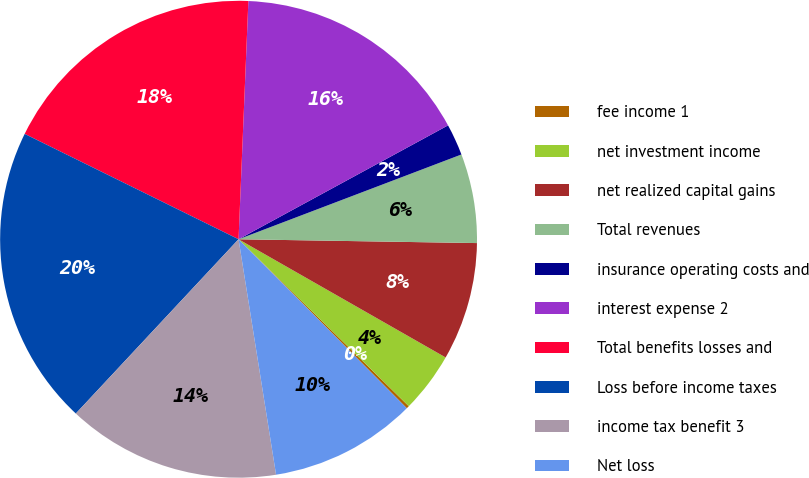<chart> <loc_0><loc_0><loc_500><loc_500><pie_chart><fcel>fee income 1<fcel>net investment income<fcel>net realized capital gains<fcel>Total revenues<fcel>insurance operating costs and<fcel>interest expense 2<fcel>Total benefits losses and<fcel>Loss before income taxes<fcel>income tax benefit 3<fcel>Net loss<nl><fcel>0.19%<fcel>4.09%<fcel>8.0%<fcel>6.04%<fcel>2.14%<fcel>16.42%<fcel>18.37%<fcel>20.33%<fcel>14.47%<fcel>9.95%<nl></chart> 